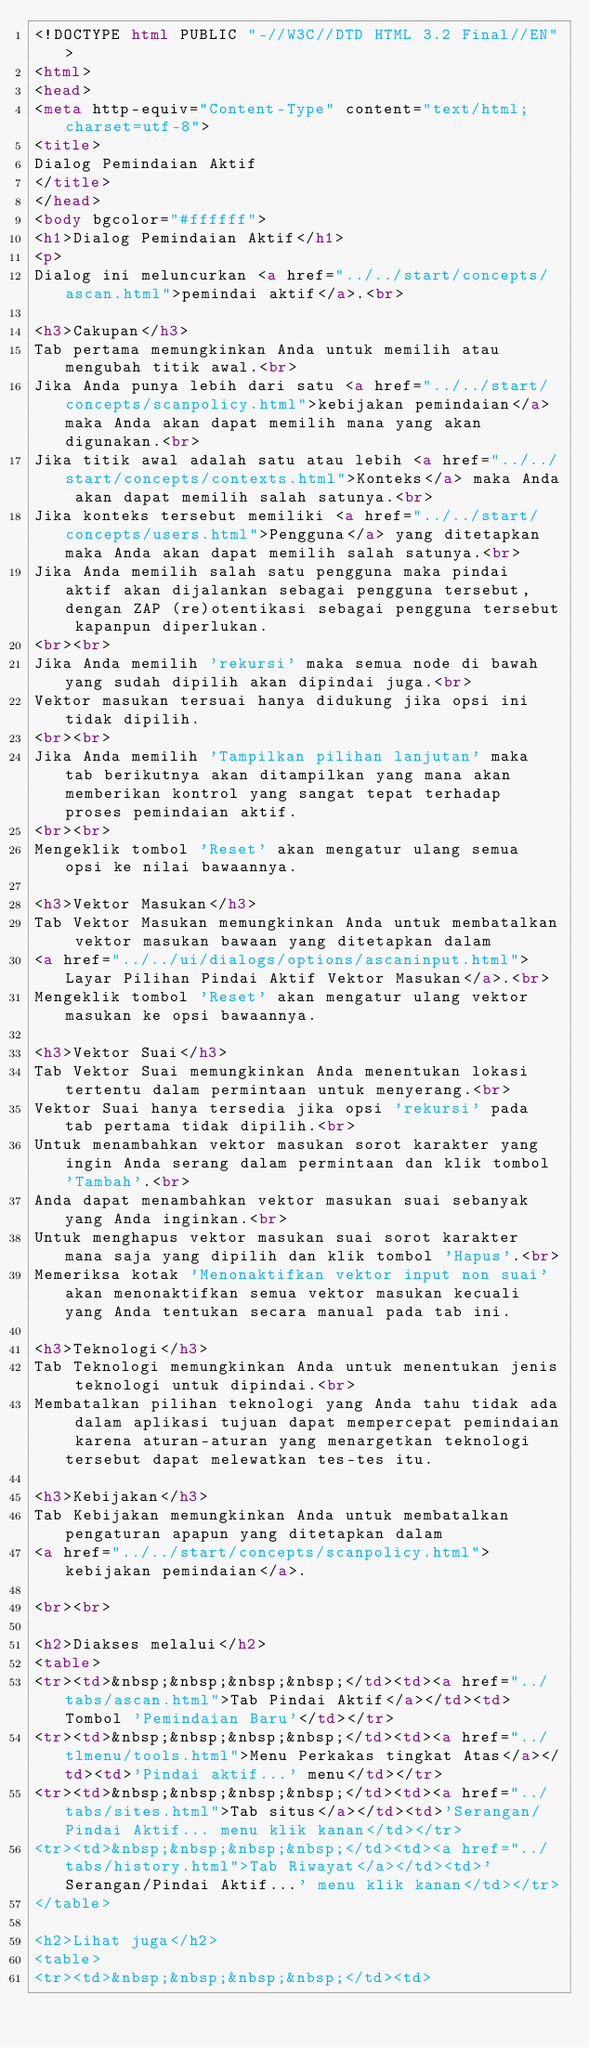Convert code to text. <code><loc_0><loc_0><loc_500><loc_500><_HTML_><!DOCTYPE html PUBLIC "-//W3C//DTD HTML 3.2 Final//EN">
<html>
<head>
<meta http-equiv="Content-Type" content="text/html; charset=utf-8">
<title>
Dialog Pemindaian Aktif
</title>
</head>
<body bgcolor="#ffffff">
<h1>Dialog Pemindaian Aktif</h1>
<p>
Dialog ini meluncurkan <a href="../../start/concepts/ascan.html">pemindai aktif</a>.<br>
  
<h3>Cakupan</h3>
Tab pertama memungkinkan Anda untuk memilih atau mengubah titik awal.<br>
Jika Anda punya lebih dari satu <a href="../../start/concepts/scanpolicy.html">kebijakan pemindaian</a> maka Anda akan dapat memilih mana yang akan digunakan.<br>
Jika titik awal adalah satu atau lebih <a href="../../start/concepts/contexts.html">Konteks</a> maka Anda akan dapat memilih salah satunya.<br>
Jika konteks tersebut memiliki <a href="../../start/concepts/users.html">Pengguna</a> yang ditetapkan maka Anda akan dapat memilih salah satunya.<br>
Jika Anda memilih salah satu pengguna maka pindai aktif akan dijalankan sebagai pengguna tersebut, dengan ZAP (re)otentikasi sebagai pengguna tersebut kapanpun diperlukan.
<br><br>
Jika Anda memilih 'rekursi' maka semua node di bawah yang sudah dipilih akan dipindai juga.<br>
Vektor masukan tersuai hanya didukung jika opsi ini tidak dipilih.
<br><br>
Jika Anda memilih 'Tampilkan pilihan lanjutan' maka tab berikutnya akan ditampilkan yang mana akan memberikan kontrol yang sangat tepat terhadap proses pemindaian aktif.
<br><br>
Mengeklik tombol 'Reset' akan mengatur ulang semua opsi ke nilai bawaannya. 

<h3>Vektor Masukan</h3>
Tab Vektor Masukan memungkinkan Anda untuk membatalkan vektor masukan bawaan yang ditetapkan dalam 
<a href="../../ui/dialogs/options/ascaninput.html">Layar Pilihan Pindai Aktif Vektor Masukan</a>.<br>
Mengeklik tombol 'Reset' akan mengatur ulang vektor masukan ke opsi bawaannya. 

<h3>Vektor Suai</h3>
Tab Vektor Suai memungkinkan Anda menentukan lokasi tertentu dalam permintaan untuk menyerang.<br> 
Vektor Suai hanya tersedia jika opsi 'rekursi' pada tab pertama tidak dipilih.<br>
Untuk menambahkan vektor masukan sorot karakter yang ingin Anda serang dalam permintaan dan klik tombol 'Tambah'.<br>
Anda dapat menambahkan vektor masukan suai sebanyak yang Anda inginkan.<br>
Untuk menghapus vektor masukan suai sorot karakter mana saja yang dipilih dan klik tombol 'Hapus'.<br>
Memeriksa kotak 'Menonaktifkan vektor input non suai' akan menonaktifkan semua vektor masukan kecuali yang Anda tentukan secara manual pada tab ini.

<h3>Teknologi</h3>
Tab Teknologi memungkinkan Anda untuk menentukan jenis teknologi untuk dipindai.<br>
Membatalkan pilihan teknologi yang Anda tahu tidak ada dalam aplikasi tujuan dapat mempercepat pemindaian karena aturan-aturan yang menargetkan teknologi tersebut dapat melewatkan tes-tes itu.

<h3>Kebijakan</h3>
Tab Kebijakan memungkinkan Anda untuk membatalkan pengaturan apapun yang ditetapkan dalam 
<a href="../../start/concepts/scanpolicy.html">kebijakan pemindaian</a>. 

<br><br>

<h2>Diakses melalui</h2>
<table>
<tr><td>&nbsp;&nbsp;&nbsp;&nbsp;</td><td><a href="../tabs/ascan.html">Tab Pindai Aktif</a></td><td>Tombol 'Pemindaian Baru'</td></tr>
<tr><td>&nbsp;&nbsp;&nbsp;&nbsp;</td><td><a href="../tlmenu/tools.html">Menu Perkakas tingkat Atas</a></td><td>'Pindai aktif...' menu</td></tr>
<tr><td>&nbsp;&nbsp;&nbsp;&nbsp;</td><td><a href="../tabs/sites.html">Tab situs</a></td><td>'Serangan/Pindai Aktif... menu klik kanan</td></tr>
<tr><td>&nbsp;&nbsp;&nbsp;&nbsp;</td><td><a href="../tabs/history.html">Tab Riwayat</a></td><td>'Serangan/Pindai Aktif...' menu klik kanan</td></tr>
</table>

<h2>Lihat juga</h2>
<table>
<tr><td>&nbsp;&nbsp;&nbsp;&nbsp;</td><td></code> 